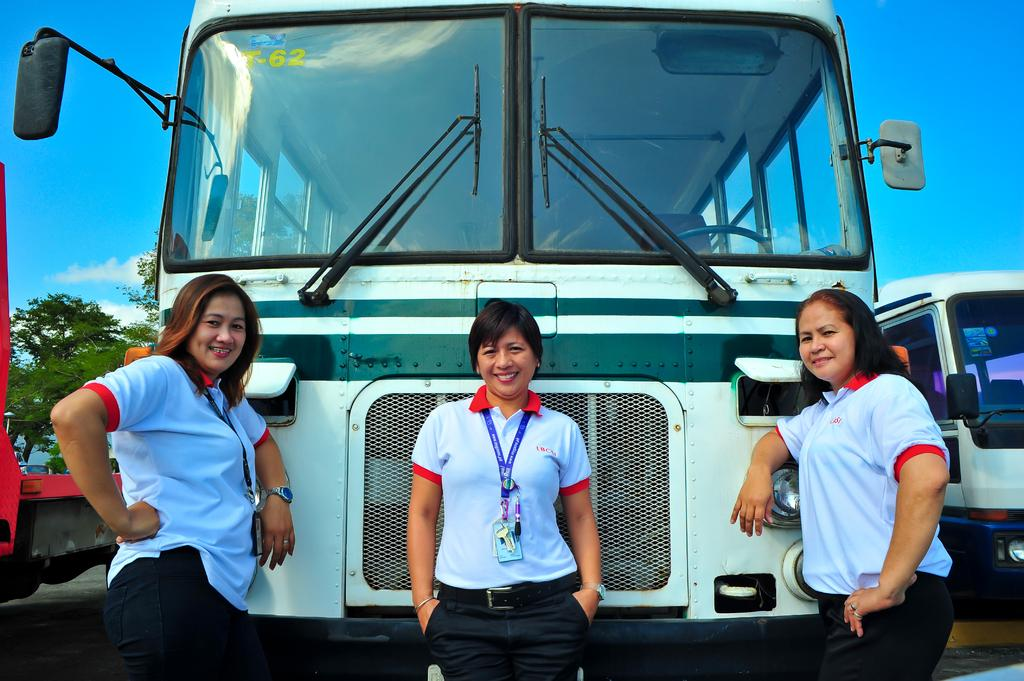How many women are in the image? There are three women in the image. What expression do the women have? The women are smiling. What can be seen in the background of the image? There are vehicles, trees, and the sky visible in the background of the image. What is the condition of the sky in the image? Clouds are present in the sky. Are the women in the image slaves? There is no indication in the image that the women are slaves; they are smiling and not depicted in any context that suggests slavery. What taste can be experienced from the image? The image does not depict any food or drink, so it is not possible to determine a taste from the image. 